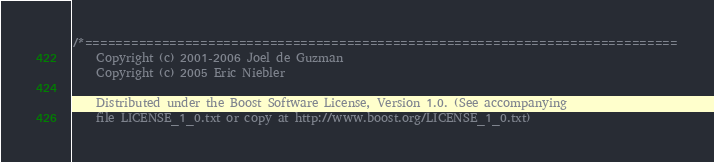<code> <loc_0><loc_0><loc_500><loc_500><_C++_>/*=============================================================================
    Copyright (c) 2001-2006 Joel de Guzman
    Copyright (c) 2005 Eric Niebler

    Distributed under the Boost Software License, Version 1.0. (See accompanying 
    file LICENSE_1_0.txt or copy at http://www.boost.org/LICENSE_1_0.txt)</code> 